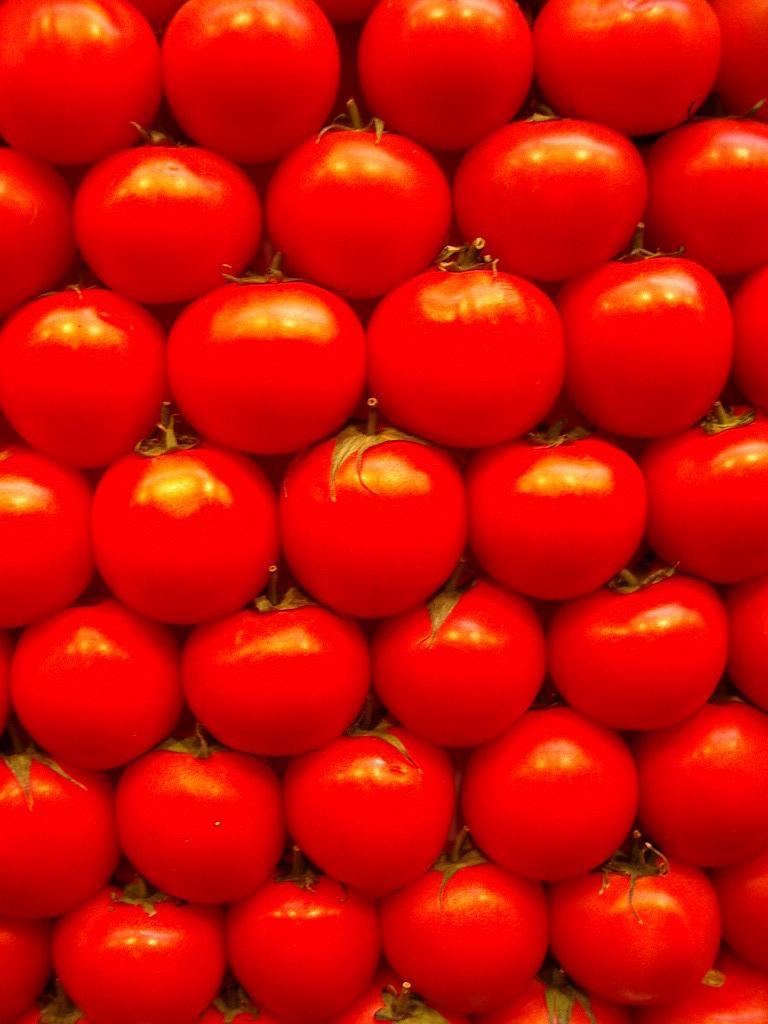Please provide a concise description of this image. In the image we can see there are lot of red colour tomatoes. 